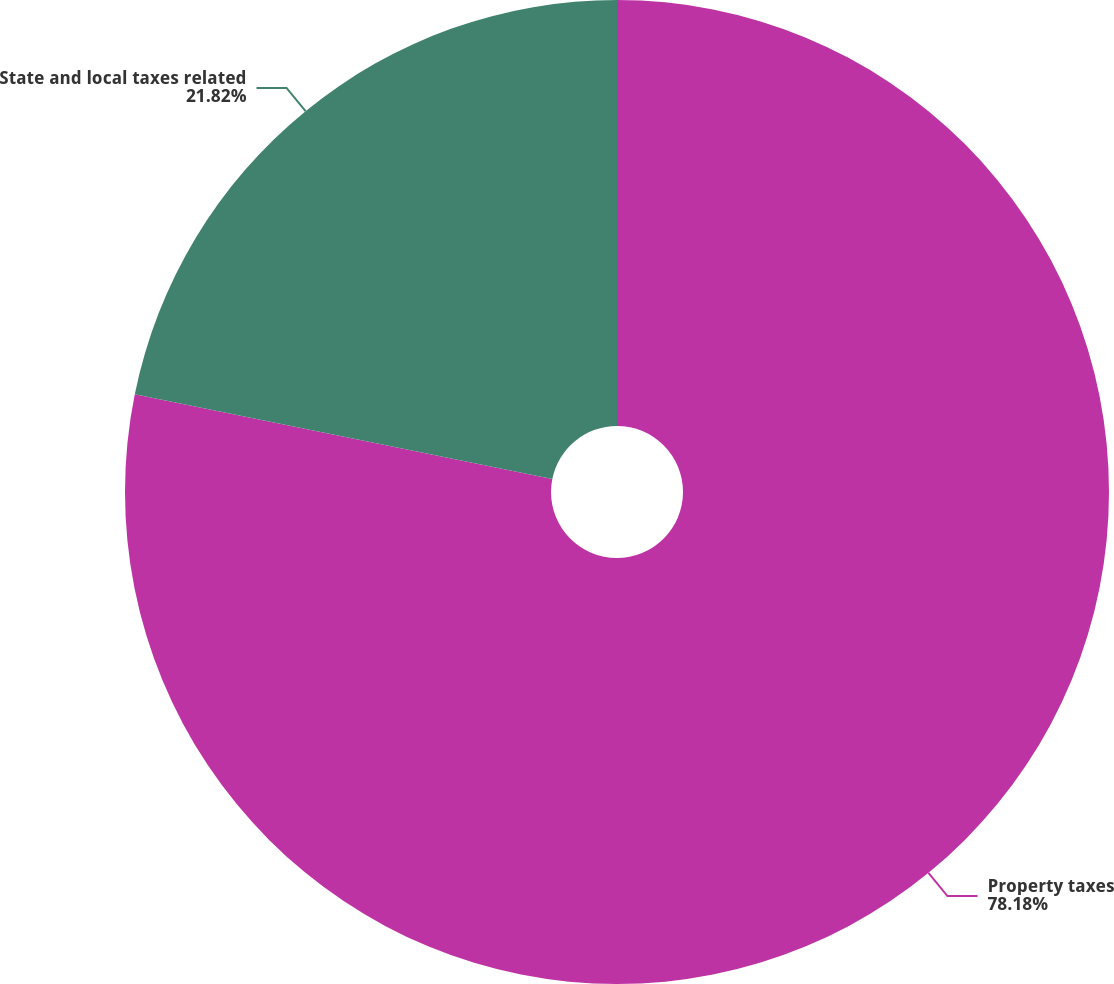Convert chart. <chart><loc_0><loc_0><loc_500><loc_500><pie_chart><fcel>Property taxes<fcel>State and local taxes related<nl><fcel>78.18%<fcel>21.82%<nl></chart> 